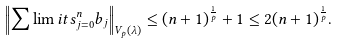Convert formula to latex. <formula><loc_0><loc_0><loc_500><loc_500>\left \| \sum \lim i t s _ { j = 0 } ^ { n } b _ { j } \right \| _ { V _ { p } ( \lambda ) } \leq ( n + 1 ) ^ { \frac { 1 } { p } } + 1 \leq 2 ( n + 1 ) ^ { \frac { 1 } { p } } .</formula> 